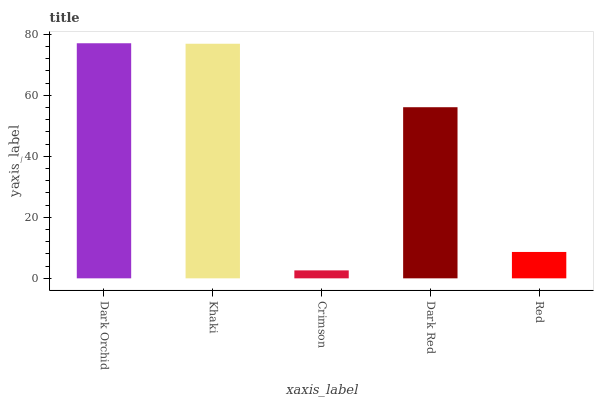Is Khaki the minimum?
Answer yes or no. No. Is Khaki the maximum?
Answer yes or no. No. Is Dark Orchid greater than Khaki?
Answer yes or no. Yes. Is Khaki less than Dark Orchid?
Answer yes or no. Yes. Is Khaki greater than Dark Orchid?
Answer yes or no. No. Is Dark Orchid less than Khaki?
Answer yes or no. No. Is Dark Red the high median?
Answer yes or no. Yes. Is Dark Red the low median?
Answer yes or no. Yes. Is Red the high median?
Answer yes or no. No. Is Khaki the low median?
Answer yes or no. No. 